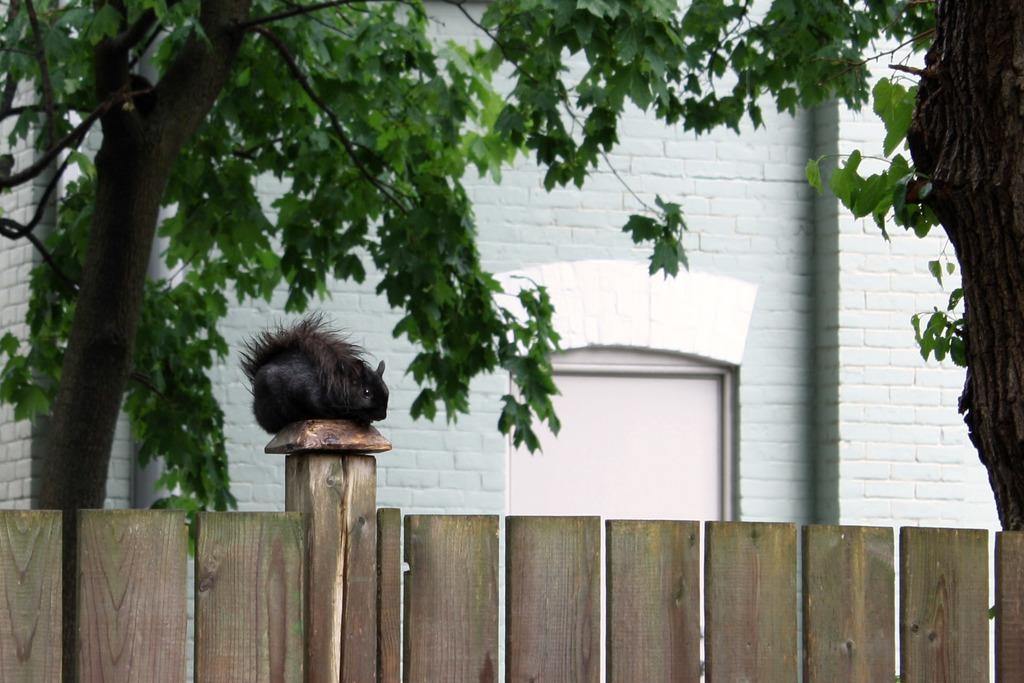What type of animal can be seen in the image? There is an animal in the image, but its specific type is not mentioned in the facts. Where is the animal located in the image? The animal is sitting on a wooden fence in the image. What can be seen in the background of the image? There are trees and a building in the background of the image, as well as a door. Can you tell me how many seats are available for the animal in the image? There is no mention of seats in the image, as the animal is sitting on a wooden fence. Is the animal touching the trees in the background of the image? The image does not show the animal touching the trees in the background; it is sitting on a wooden fence. 